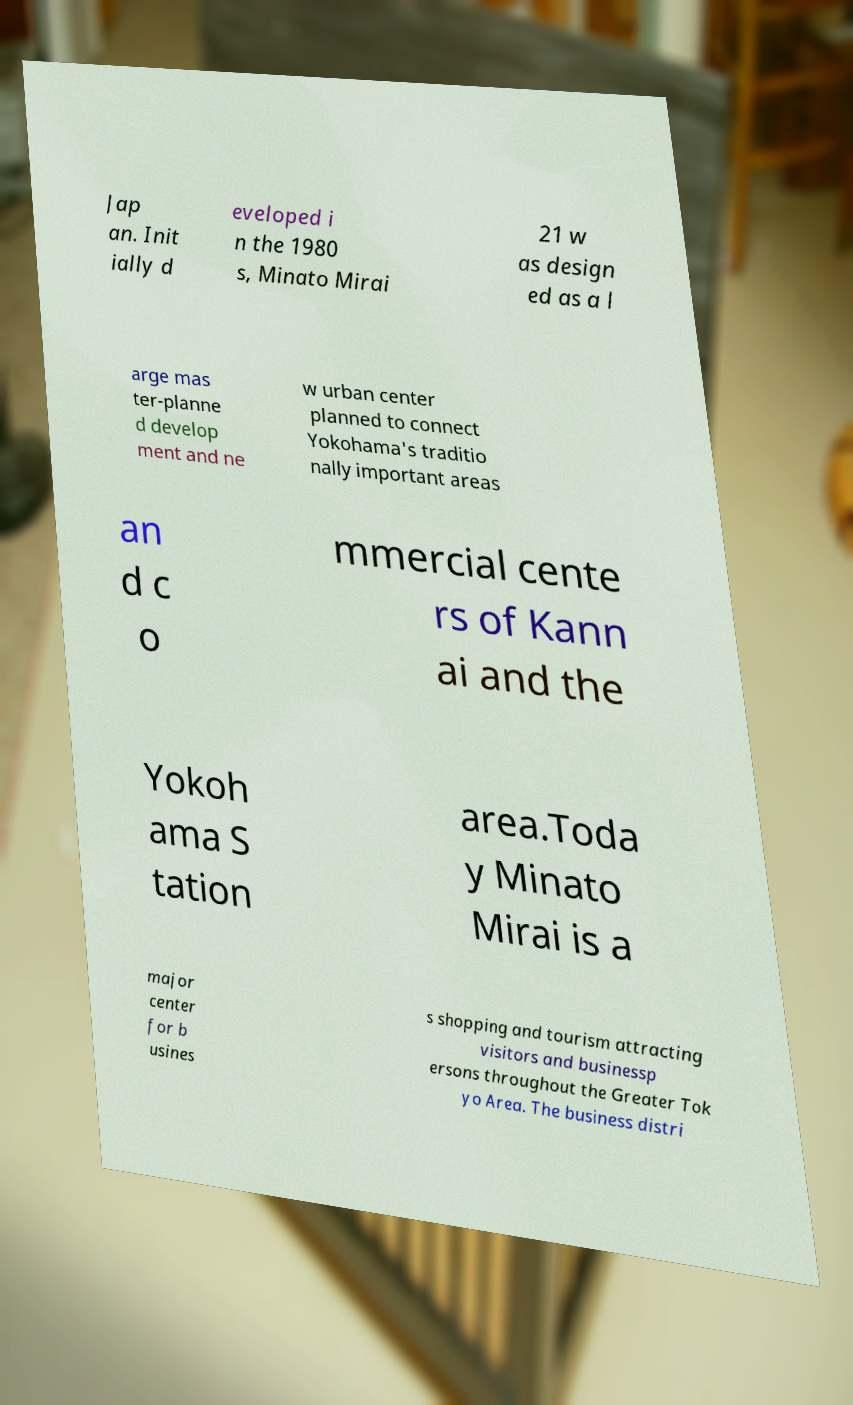Could you extract and type out the text from this image? Jap an. Init ially d eveloped i n the 1980 s, Minato Mirai 21 w as design ed as a l arge mas ter-planne d develop ment and ne w urban center planned to connect Yokohama's traditio nally important areas an d c o mmercial cente rs of Kann ai and the Yokoh ama S tation area.Toda y Minato Mirai is a major center for b usines s shopping and tourism attracting visitors and businessp ersons throughout the Greater Tok yo Area. The business distri 